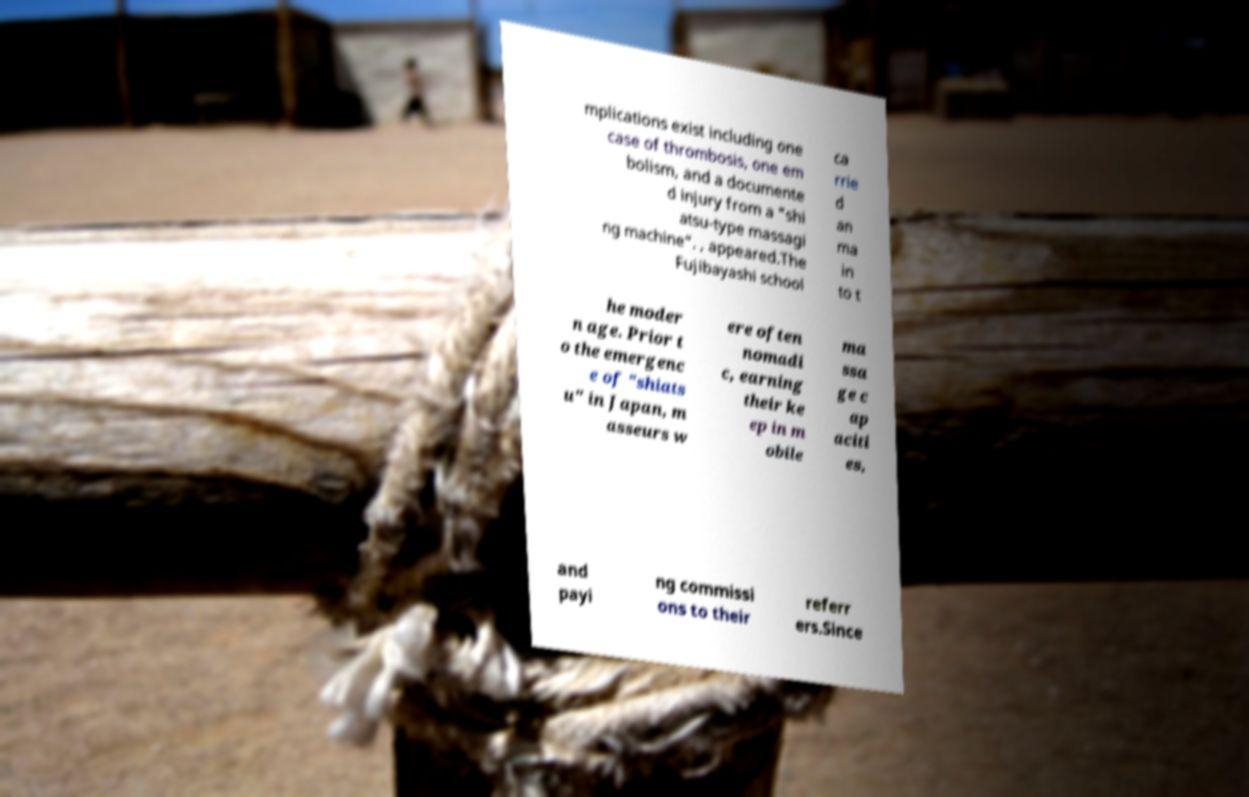Please read and relay the text visible in this image. What does it say? mplications exist including one case of thrombosis, one em bolism, and a documente d injury from a "shi atsu-type massagi ng machine". , appeared.The Fujibayashi school ca rrie d an ma in to t he moder n age. Prior t o the emergenc e of "shiats u" in Japan, m asseurs w ere often nomadi c, earning their ke ep in m obile ma ssa ge c ap aciti es, and payi ng commissi ons to their referr ers.Since 